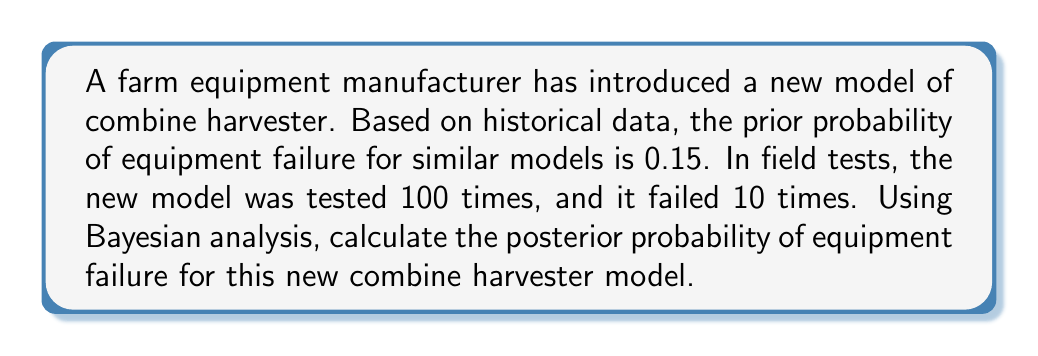Can you solve this math problem? To solve this problem using Bayesian analysis, we'll follow these steps:

1. Identify the given information:
   - Prior probability of failure (P(F)): 0.15
   - Number of tests: 100
   - Number of failures: 10

2. Calculate the likelihood of observing the data given the prior:
   The likelihood is the probability of observing 10 failures out of 100 tests, given the prior probability of failure. This follows a binomial distribution.

   $P(D|F) = \binom{100}{10} \cdot 0.15^{10} \cdot (1-0.15)^{90}$

3. Calculate the likelihood of observing the data given no failure:
   $P(D|\text{not F}) = \binom{100}{10} \cdot (1-0.15)^{10} \cdot 0.15^{90}$

4. Apply Bayes' theorem:
   $$P(F|D) = \frac{P(D|F) \cdot P(F)}{P(D|F) \cdot P(F) + P(D|\text{not F}) \cdot P(\text{not F})}$$

5. Calculate each component:
   $P(D|F) = \binom{100}{10} \cdot 0.15^{10} \cdot 0.85^{90} \approx 0.0451$
   $P(F) = 0.15$
   $P(D|\text{not F}) = \binom{100}{10} \cdot 0.85^{10} \cdot 0.15^{90} \approx 1.38 \times 10^{-65}$
   $P(\text{not F}) = 1 - 0.15 = 0.85$

6. Substitute these values into Bayes' theorem:
   $$P(F|D) = \frac{0.0451 \cdot 0.15}{0.0451 \cdot 0.15 + 1.38 \times 10^{-65} \cdot 0.85}$$

7. Simplify and calculate the final result:
   $$P(F|D) = \frac{0.006765}{0.006765 + 1.173 \times 10^{-65}} \approx 0.1000$$

The posterior probability of equipment failure for the new combine harvester model is approximately 0.1000 or 10%.
Answer: The posterior probability of equipment failure for the new combine harvester model is approximately 0.1000 or 10%. 